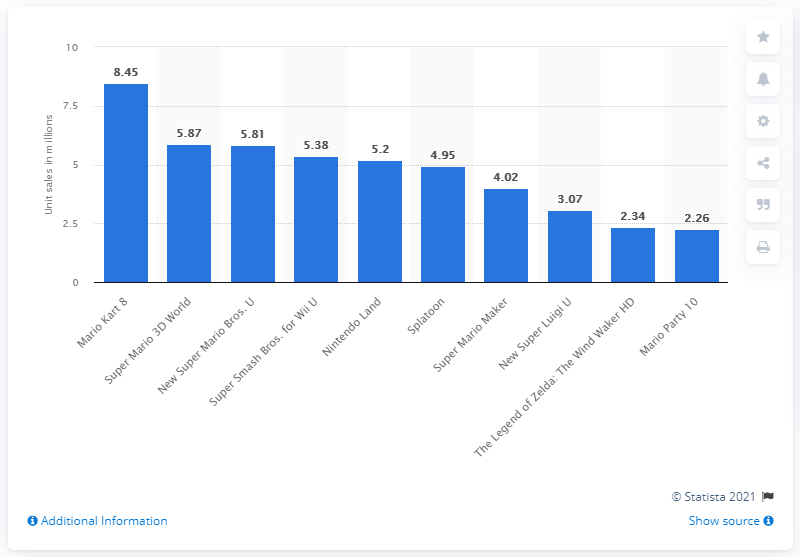List a handful of essential elements in this visual. In March 2021, a total of 8.45 units of Mario Kart 8 were sold on the Wii U. Super Mario 3D World has sold a total of 5.87 lifetime units. 